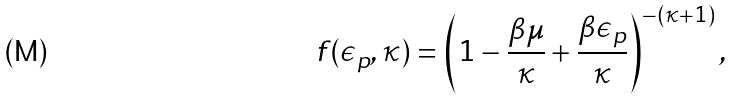<formula> <loc_0><loc_0><loc_500><loc_500>f ( \epsilon _ { p } , \kappa ) = \left ( 1 - \frac { \beta \mu } { \kappa } + \frac { \beta \epsilon _ { p } } { \kappa } \right ) ^ { - ( \kappa + 1 ) } ,</formula> 